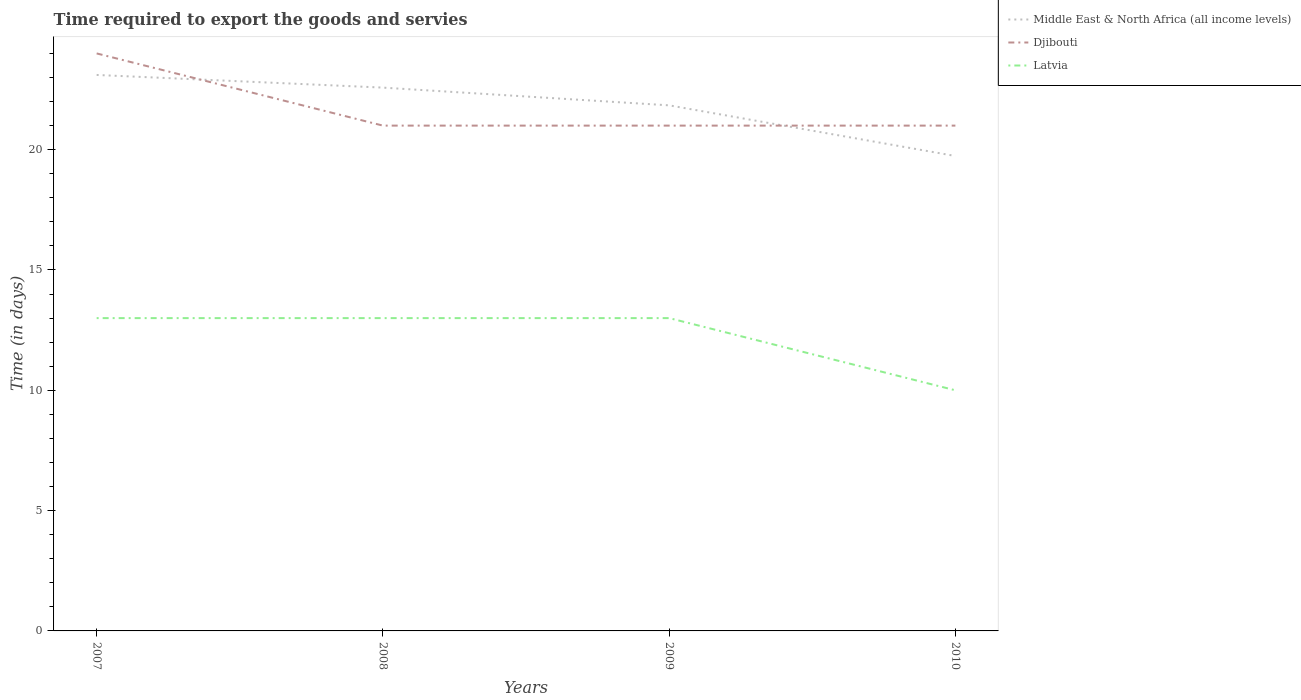Is the number of lines equal to the number of legend labels?
Your response must be concise. Yes. Across all years, what is the maximum number of days required to export the goods and services in Latvia?
Ensure brevity in your answer.  10. In which year was the number of days required to export the goods and services in Latvia maximum?
Make the answer very short. 2010. What is the total number of days required to export the goods and services in Latvia in the graph?
Your answer should be compact. 0. What is the difference between the highest and the second highest number of days required to export the goods and services in Middle East & North Africa (all income levels)?
Provide a short and direct response. 3.37. Is the number of days required to export the goods and services in Middle East & North Africa (all income levels) strictly greater than the number of days required to export the goods and services in Djibouti over the years?
Provide a succinct answer. No. How many lines are there?
Your answer should be compact. 3. What is the difference between two consecutive major ticks on the Y-axis?
Keep it short and to the point. 5. Does the graph contain any zero values?
Provide a short and direct response. No. Where does the legend appear in the graph?
Your response must be concise. Top right. How many legend labels are there?
Ensure brevity in your answer.  3. What is the title of the graph?
Make the answer very short. Time required to export the goods and servies. What is the label or title of the Y-axis?
Your answer should be compact. Time (in days). What is the Time (in days) in Middle East & North Africa (all income levels) in 2007?
Offer a very short reply. 23.11. What is the Time (in days) of Latvia in 2007?
Keep it short and to the point. 13. What is the Time (in days) in Middle East & North Africa (all income levels) in 2008?
Ensure brevity in your answer.  22.58. What is the Time (in days) in Djibouti in 2008?
Your answer should be compact. 21. What is the Time (in days) in Latvia in 2008?
Offer a terse response. 13. What is the Time (in days) of Middle East & North Africa (all income levels) in 2009?
Offer a very short reply. 21.84. What is the Time (in days) in Djibouti in 2009?
Offer a very short reply. 21. What is the Time (in days) of Latvia in 2009?
Provide a succinct answer. 13. What is the Time (in days) of Middle East & North Africa (all income levels) in 2010?
Your answer should be very brief. 19.74. What is the Time (in days) of Djibouti in 2010?
Your response must be concise. 21. What is the Time (in days) of Latvia in 2010?
Keep it short and to the point. 10. Across all years, what is the maximum Time (in days) of Middle East & North Africa (all income levels)?
Your answer should be very brief. 23.11. Across all years, what is the minimum Time (in days) of Middle East & North Africa (all income levels)?
Your response must be concise. 19.74. Across all years, what is the minimum Time (in days) in Djibouti?
Make the answer very short. 21. Across all years, what is the minimum Time (in days) of Latvia?
Provide a succinct answer. 10. What is the total Time (in days) in Middle East & North Africa (all income levels) in the graph?
Offer a terse response. 87.26. What is the total Time (in days) of Djibouti in the graph?
Ensure brevity in your answer.  87. What is the total Time (in days) in Latvia in the graph?
Ensure brevity in your answer.  49. What is the difference between the Time (in days) of Middle East & North Africa (all income levels) in 2007 and that in 2008?
Your response must be concise. 0.53. What is the difference between the Time (in days) in Djibouti in 2007 and that in 2008?
Your answer should be very brief. 3. What is the difference between the Time (in days) of Middle East & North Africa (all income levels) in 2007 and that in 2009?
Provide a succinct answer. 1.26. What is the difference between the Time (in days) of Latvia in 2007 and that in 2009?
Provide a succinct answer. 0. What is the difference between the Time (in days) of Middle East & North Africa (all income levels) in 2007 and that in 2010?
Make the answer very short. 3.37. What is the difference between the Time (in days) in Latvia in 2007 and that in 2010?
Your answer should be compact. 3. What is the difference between the Time (in days) of Middle East & North Africa (all income levels) in 2008 and that in 2009?
Make the answer very short. 0.74. What is the difference between the Time (in days) of Djibouti in 2008 and that in 2009?
Give a very brief answer. 0. What is the difference between the Time (in days) of Latvia in 2008 and that in 2009?
Give a very brief answer. 0. What is the difference between the Time (in days) in Middle East & North Africa (all income levels) in 2008 and that in 2010?
Keep it short and to the point. 2.84. What is the difference between the Time (in days) of Latvia in 2008 and that in 2010?
Make the answer very short. 3. What is the difference between the Time (in days) of Middle East & North Africa (all income levels) in 2009 and that in 2010?
Your answer should be very brief. 2.11. What is the difference between the Time (in days) in Latvia in 2009 and that in 2010?
Your response must be concise. 3. What is the difference between the Time (in days) in Middle East & North Africa (all income levels) in 2007 and the Time (in days) in Djibouti in 2008?
Ensure brevity in your answer.  2.11. What is the difference between the Time (in days) of Middle East & North Africa (all income levels) in 2007 and the Time (in days) of Latvia in 2008?
Your answer should be compact. 10.11. What is the difference between the Time (in days) in Djibouti in 2007 and the Time (in days) in Latvia in 2008?
Offer a very short reply. 11. What is the difference between the Time (in days) of Middle East & North Africa (all income levels) in 2007 and the Time (in days) of Djibouti in 2009?
Offer a very short reply. 2.11. What is the difference between the Time (in days) of Middle East & North Africa (all income levels) in 2007 and the Time (in days) of Latvia in 2009?
Keep it short and to the point. 10.11. What is the difference between the Time (in days) of Middle East & North Africa (all income levels) in 2007 and the Time (in days) of Djibouti in 2010?
Offer a terse response. 2.11. What is the difference between the Time (in days) in Middle East & North Africa (all income levels) in 2007 and the Time (in days) in Latvia in 2010?
Offer a very short reply. 13.11. What is the difference between the Time (in days) of Middle East & North Africa (all income levels) in 2008 and the Time (in days) of Djibouti in 2009?
Your answer should be compact. 1.58. What is the difference between the Time (in days) in Middle East & North Africa (all income levels) in 2008 and the Time (in days) in Latvia in 2009?
Give a very brief answer. 9.58. What is the difference between the Time (in days) in Djibouti in 2008 and the Time (in days) in Latvia in 2009?
Your answer should be compact. 8. What is the difference between the Time (in days) in Middle East & North Africa (all income levels) in 2008 and the Time (in days) in Djibouti in 2010?
Provide a succinct answer. 1.58. What is the difference between the Time (in days) in Middle East & North Africa (all income levels) in 2008 and the Time (in days) in Latvia in 2010?
Your answer should be compact. 12.58. What is the difference between the Time (in days) of Djibouti in 2008 and the Time (in days) of Latvia in 2010?
Your answer should be compact. 11. What is the difference between the Time (in days) in Middle East & North Africa (all income levels) in 2009 and the Time (in days) in Djibouti in 2010?
Make the answer very short. 0.84. What is the difference between the Time (in days) of Middle East & North Africa (all income levels) in 2009 and the Time (in days) of Latvia in 2010?
Offer a terse response. 11.84. What is the average Time (in days) of Middle East & North Africa (all income levels) per year?
Provide a short and direct response. 21.82. What is the average Time (in days) of Djibouti per year?
Your response must be concise. 21.75. What is the average Time (in days) in Latvia per year?
Your response must be concise. 12.25. In the year 2007, what is the difference between the Time (in days) in Middle East & North Africa (all income levels) and Time (in days) in Djibouti?
Your answer should be compact. -0.89. In the year 2007, what is the difference between the Time (in days) of Middle East & North Africa (all income levels) and Time (in days) of Latvia?
Offer a very short reply. 10.11. In the year 2007, what is the difference between the Time (in days) of Djibouti and Time (in days) of Latvia?
Ensure brevity in your answer.  11. In the year 2008, what is the difference between the Time (in days) of Middle East & North Africa (all income levels) and Time (in days) of Djibouti?
Your response must be concise. 1.58. In the year 2008, what is the difference between the Time (in days) in Middle East & North Africa (all income levels) and Time (in days) in Latvia?
Your answer should be compact. 9.58. In the year 2009, what is the difference between the Time (in days) in Middle East & North Africa (all income levels) and Time (in days) in Djibouti?
Your answer should be very brief. 0.84. In the year 2009, what is the difference between the Time (in days) in Middle East & North Africa (all income levels) and Time (in days) in Latvia?
Keep it short and to the point. 8.84. In the year 2010, what is the difference between the Time (in days) in Middle East & North Africa (all income levels) and Time (in days) in Djibouti?
Make the answer very short. -1.26. In the year 2010, what is the difference between the Time (in days) in Middle East & North Africa (all income levels) and Time (in days) in Latvia?
Provide a short and direct response. 9.74. What is the ratio of the Time (in days) of Middle East & North Africa (all income levels) in 2007 to that in 2008?
Provide a succinct answer. 1.02. What is the ratio of the Time (in days) of Djibouti in 2007 to that in 2008?
Your response must be concise. 1.14. What is the ratio of the Time (in days) of Middle East & North Africa (all income levels) in 2007 to that in 2009?
Your answer should be compact. 1.06. What is the ratio of the Time (in days) of Middle East & North Africa (all income levels) in 2007 to that in 2010?
Provide a short and direct response. 1.17. What is the ratio of the Time (in days) in Middle East & North Africa (all income levels) in 2008 to that in 2009?
Your response must be concise. 1.03. What is the ratio of the Time (in days) of Djibouti in 2008 to that in 2009?
Your response must be concise. 1. What is the ratio of the Time (in days) of Middle East & North Africa (all income levels) in 2008 to that in 2010?
Your answer should be very brief. 1.14. What is the ratio of the Time (in days) of Latvia in 2008 to that in 2010?
Offer a very short reply. 1.3. What is the ratio of the Time (in days) in Middle East & North Africa (all income levels) in 2009 to that in 2010?
Provide a succinct answer. 1.11. What is the difference between the highest and the second highest Time (in days) in Middle East & North Africa (all income levels)?
Offer a terse response. 0.53. What is the difference between the highest and the second highest Time (in days) of Latvia?
Keep it short and to the point. 0. What is the difference between the highest and the lowest Time (in days) in Middle East & North Africa (all income levels)?
Offer a terse response. 3.37. What is the difference between the highest and the lowest Time (in days) of Djibouti?
Your answer should be compact. 3. What is the difference between the highest and the lowest Time (in days) in Latvia?
Offer a very short reply. 3. 